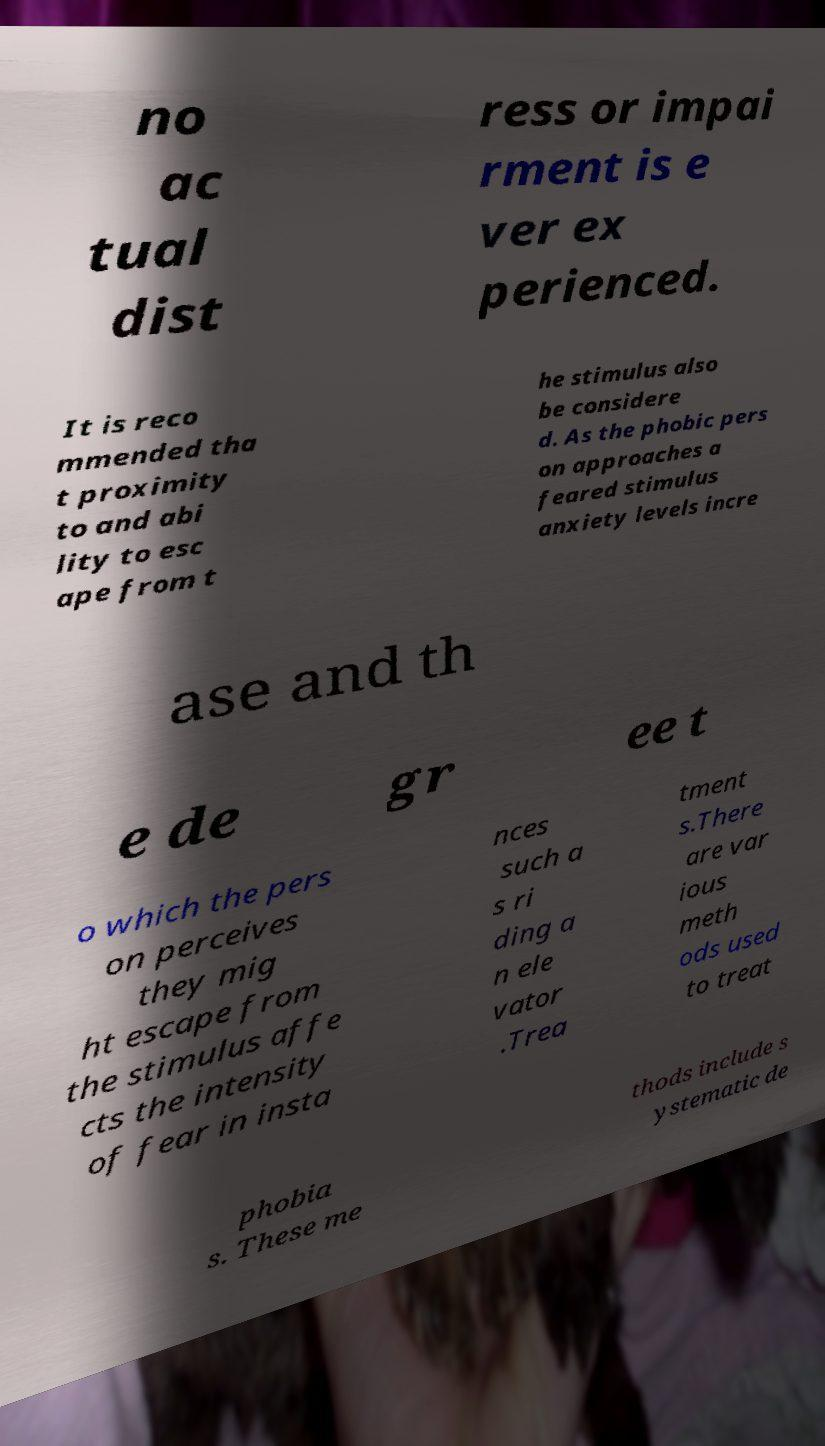There's text embedded in this image that I need extracted. Can you transcribe it verbatim? no ac tual dist ress or impai rment is e ver ex perienced. It is reco mmended tha t proximity to and abi lity to esc ape from t he stimulus also be considere d. As the phobic pers on approaches a feared stimulus anxiety levels incre ase and th e de gr ee t o which the pers on perceives they mig ht escape from the stimulus affe cts the intensity of fear in insta nces such a s ri ding a n ele vator .Trea tment s.There are var ious meth ods used to treat phobia s. These me thods include s ystematic de 